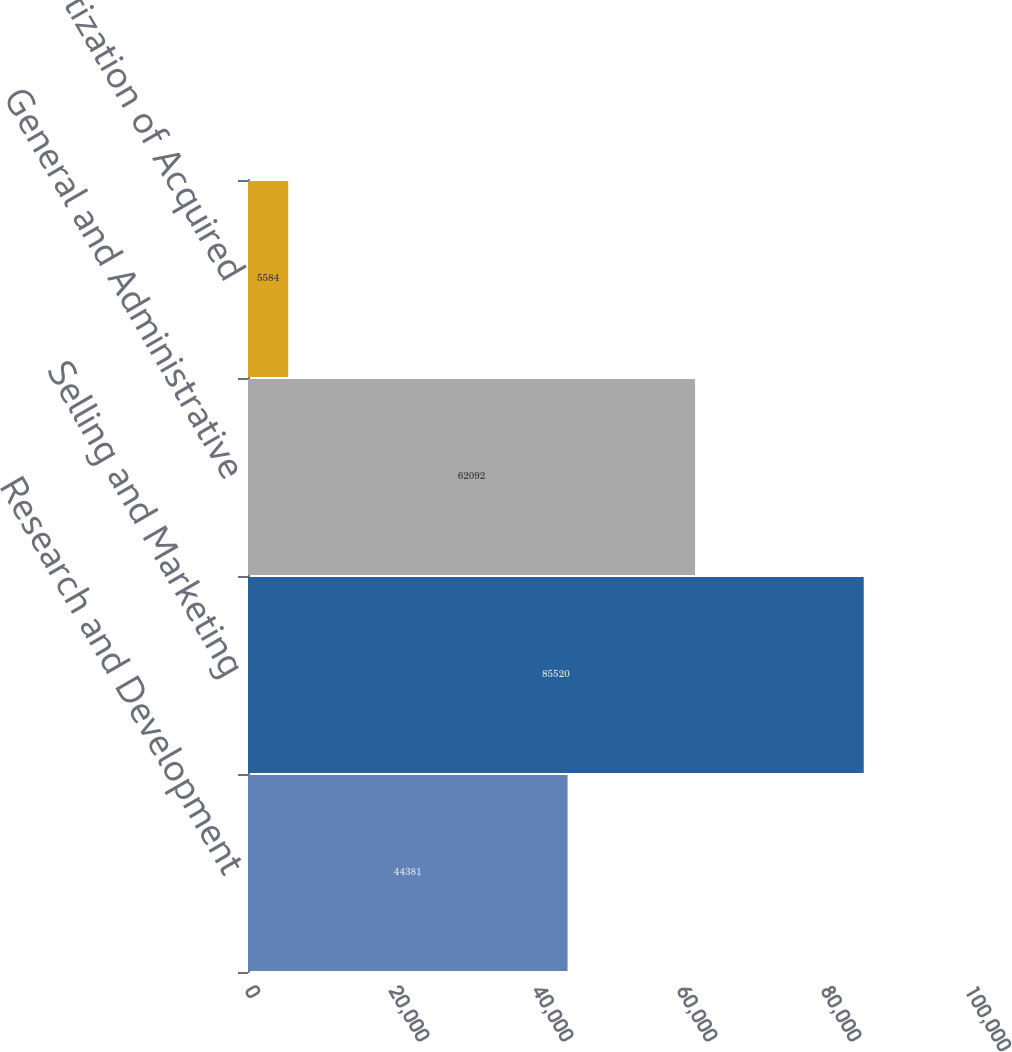Convert chart to OTSL. <chart><loc_0><loc_0><loc_500><loc_500><bar_chart><fcel>Research and Development<fcel>Selling and Marketing<fcel>General and Administrative<fcel>Amortization of Acquired<nl><fcel>44381<fcel>85520<fcel>62092<fcel>5584<nl></chart> 